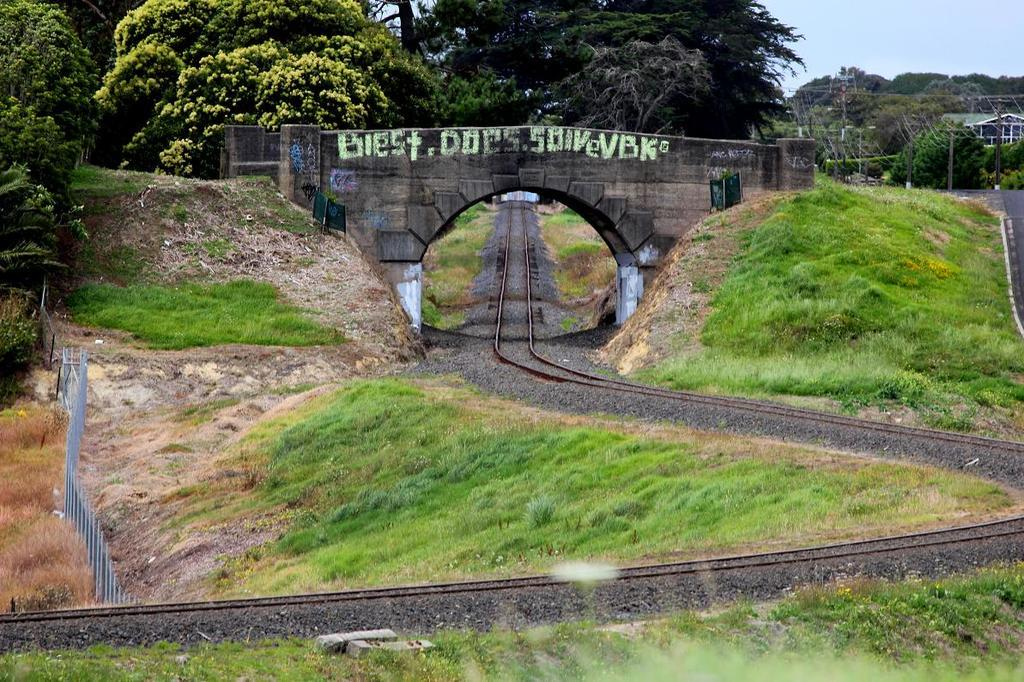<image>
Share a concise interpretation of the image provided. German graffiti on a stone bridge over a railroad tracks. 